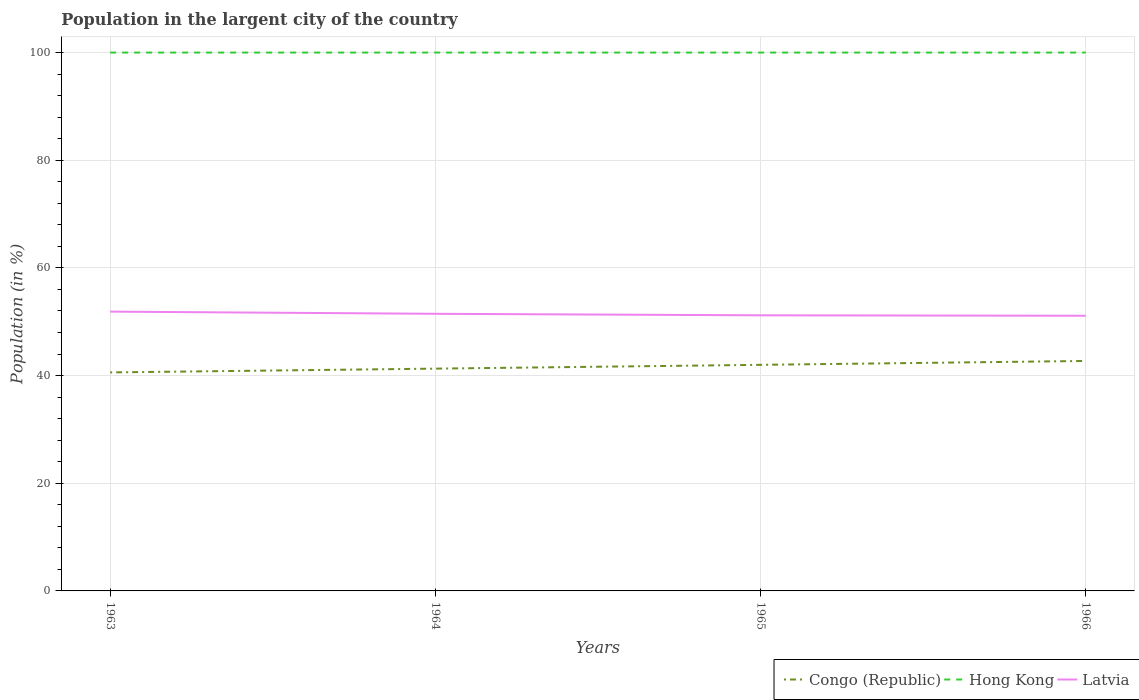Is the number of lines equal to the number of legend labels?
Offer a terse response. Yes. Across all years, what is the maximum percentage of population in the largent city in Latvia?
Give a very brief answer. 51.11. In which year was the percentage of population in the largent city in Latvia maximum?
Give a very brief answer. 1966. What is the total percentage of population in the largent city in Congo (Republic) in the graph?
Keep it short and to the point. -1.41. What is the difference between the highest and the second highest percentage of population in the largent city in Latvia?
Your answer should be compact. 0.77. What is the difference between the highest and the lowest percentage of population in the largent city in Hong Kong?
Offer a terse response. 0. Is the percentage of population in the largent city in Latvia strictly greater than the percentage of population in the largent city in Hong Kong over the years?
Provide a short and direct response. Yes. How many lines are there?
Keep it short and to the point. 3. How many years are there in the graph?
Ensure brevity in your answer.  4. What is the title of the graph?
Offer a very short reply. Population in the largent city of the country. Does "Russian Federation" appear as one of the legend labels in the graph?
Ensure brevity in your answer.  No. What is the Population (in %) of Congo (Republic) in 1963?
Provide a succinct answer. 40.59. What is the Population (in %) of Hong Kong in 1963?
Your response must be concise. 100. What is the Population (in %) in Latvia in 1963?
Make the answer very short. 51.88. What is the Population (in %) in Congo (Republic) in 1964?
Your response must be concise. 41.29. What is the Population (in %) of Latvia in 1964?
Offer a terse response. 51.48. What is the Population (in %) of Congo (Republic) in 1965?
Your answer should be very brief. 42. What is the Population (in %) in Latvia in 1965?
Offer a terse response. 51.19. What is the Population (in %) of Congo (Republic) in 1966?
Give a very brief answer. 42.72. What is the Population (in %) in Hong Kong in 1966?
Your answer should be compact. 100. What is the Population (in %) in Latvia in 1966?
Make the answer very short. 51.11. Across all years, what is the maximum Population (in %) of Congo (Republic)?
Provide a succinct answer. 42.72. Across all years, what is the maximum Population (in %) of Latvia?
Offer a very short reply. 51.88. Across all years, what is the minimum Population (in %) of Congo (Republic)?
Your answer should be compact. 40.59. Across all years, what is the minimum Population (in %) in Hong Kong?
Make the answer very short. 100. Across all years, what is the minimum Population (in %) in Latvia?
Keep it short and to the point. 51.11. What is the total Population (in %) of Congo (Republic) in the graph?
Offer a terse response. 166.59. What is the total Population (in %) in Latvia in the graph?
Give a very brief answer. 205.66. What is the difference between the Population (in %) of Congo (Republic) in 1963 and that in 1964?
Keep it short and to the point. -0.7. What is the difference between the Population (in %) in Latvia in 1963 and that in 1964?
Provide a short and direct response. 0.4. What is the difference between the Population (in %) in Congo (Republic) in 1963 and that in 1965?
Ensure brevity in your answer.  -1.41. What is the difference between the Population (in %) of Hong Kong in 1963 and that in 1965?
Make the answer very short. 0. What is the difference between the Population (in %) of Latvia in 1963 and that in 1965?
Offer a terse response. 0.69. What is the difference between the Population (in %) of Congo (Republic) in 1963 and that in 1966?
Offer a very short reply. -2.13. What is the difference between the Population (in %) in Hong Kong in 1963 and that in 1966?
Your response must be concise. 0. What is the difference between the Population (in %) in Latvia in 1963 and that in 1966?
Offer a terse response. 0.77. What is the difference between the Population (in %) of Congo (Republic) in 1964 and that in 1965?
Make the answer very short. -0.71. What is the difference between the Population (in %) of Latvia in 1964 and that in 1965?
Make the answer very short. 0.28. What is the difference between the Population (in %) of Congo (Republic) in 1964 and that in 1966?
Your answer should be compact. -1.43. What is the difference between the Population (in %) of Hong Kong in 1964 and that in 1966?
Offer a terse response. 0. What is the difference between the Population (in %) of Latvia in 1964 and that in 1966?
Your response must be concise. 0.36. What is the difference between the Population (in %) of Congo (Republic) in 1965 and that in 1966?
Offer a terse response. -0.72. What is the difference between the Population (in %) of Hong Kong in 1965 and that in 1966?
Your answer should be very brief. 0. What is the difference between the Population (in %) of Latvia in 1965 and that in 1966?
Offer a terse response. 0.08. What is the difference between the Population (in %) in Congo (Republic) in 1963 and the Population (in %) in Hong Kong in 1964?
Your answer should be very brief. -59.41. What is the difference between the Population (in %) of Congo (Republic) in 1963 and the Population (in %) of Latvia in 1964?
Offer a very short reply. -10.89. What is the difference between the Population (in %) of Hong Kong in 1963 and the Population (in %) of Latvia in 1964?
Offer a very short reply. 48.52. What is the difference between the Population (in %) in Congo (Republic) in 1963 and the Population (in %) in Hong Kong in 1965?
Give a very brief answer. -59.41. What is the difference between the Population (in %) of Congo (Republic) in 1963 and the Population (in %) of Latvia in 1965?
Give a very brief answer. -10.61. What is the difference between the Population (in %) in Hong Kong in 1963 and the Population (in %) in Latvia in 1965?
Make the answer very short. 48.81. What is the difference between the Population (in %) in Congo (Republic) in 1963 and the Population (in %) in Hong Kong in 1966?
Your response must be concise. -59.41. What is the difference between the Population (in %) of Congo (Republic) in 1963 and the Population (in %) of Latvia in 1966?
Provide a succinct answer. -10.52. What is the difference between the Population (in %) of Hong Kong in 1963 and the Population (in %) of Latvia in 1966?
Your answer should be very brief. 48.89. What is the difference between the Population (in %) of Congo (Republic) in 1964 and the Population (in %) of Hong Kong in 1965?
Give a very brief answer. -58.71. What is the difference between the Population (in %) of Congo (Republic) in 1964 and the Population (in %) of Latvia in 1965?
Make the answer very short. -9.9. What is the difference between the Population (in %) of Hong Kong in 1964 and the Population (in %) of Latvia in 1965?
Make the answer very short. 48.81. What is the difference between the Population (in %) in Congo (Republic) in 1964 and the Population (in %) in Hong Kong in 1966?
Your response must be concise. -58.71. What is the difference between the Population (in %) of Congo (Republic) in 1964 and the Population (in %) of Latvia in 1966?
Offer a terse response. -9.82. What is the difference between the Population (in %) in Hong Kong in 1964 and the Population (in %) in Latvia in 1966?
Make the answer very short. 48.89. What is the difference between the Population (in %) in Congo (Republic) in 1965 and the Population (in %) in Hong Kong in 1966?
Ensure brevity in your answer.  -58. What is the difference between the Population (in %) in Congo (Republic) in 1965 and the Population (in %) in Latvia in 1966?
Provide a succinct answer. -9.12. What is the difference between the Population (in %) in Hong Kong in 1965 and the Population (in %) in Latvia in 1966?
Ensure brevity in your answer.  48.89. What is the average Population (in %) in Congo (Republic) per year?
Give a very brief answer. 41.65. What is the average Population (in %) of Hong Kong per year?
Your response must be concise. 100. What is the average Population (in %) of Latvia per year?
Your answer should be compact. 51.42. In the year 1963, what is the difference between the Population (in %) of Congo (Republic) and Population (in %) of Hong Kong?
Make the answer very short. -59.41. In the year 1963, what is the difference between the Population (in %) in Congo (Republic) and Population (in %) in Latvia?
Give a very brief answer. -11.29. In the year 1963, what is the difference between the Population (in %) of Hong Kong and Population (in %) of Latvia?
Make the answer very short. 48.12. In the year 1964, what is the difference between the Population (in %) in Congo (Republic) and Population (in %) in Hong Kong?
Ensure brevity in your answer.  -58.71. In the year 1964, what is the difference between the Population (in %) of Congo (Republic) and Population (in %) of Latvia?
Ensure brevity in your answer.  -10.18. In the year 1964, what is the difference between the Population (in %) in Hong Kong and Population (in %) in Latvia?
Make the answer very short. 48.52. In the year 1965, what is the difference between the Population (in %) of Congo (Republic) and Population (in %) of Hong Kong?
Keep it short and to the point. -58. In the year 1965, what is the difference between the Population (in %) of Congo (Republic) and Population (in %) of Latvia?
Your response must be concise. -9.2. In the year 1965, what is the difference between the Population (in %) of Hong Kong and Population (in %) of Latvia?
Keep it short and to the point. 48.81. In the year 1966, what is the difference between the Population (in %) in Congo (Republic) and Population (in %) in Hong Kong?
Provide a short and direct response. -57.28. In the year 1966, what is the difference between the Population (in %) of Congo (Republic) and Population (in %) of Latvia?
Keep it short and to the point. -8.4. In the year 1966, what is the difference between the Population (in %) of Hong Kong and Population (in %) of Latvia?
Your answer should be very brief. 48.89. What is the ratio of the Population (in %) in Congo (Republic) in 1963 to that in 1964?
Give a very brief answer. 0.98. What is the ratio of the Population (in %) of Hong Kong in 1963 to that in 1964?
Keep it short and to the point. 1. What is the ratio of the Population (in %) of Latvia in 1963 to that in 1964?
Offer a terse response. 1.01. What is the ratio of the Population (in %) in Congo (Republic) in 1963 to that in 1965?
Keep it short and to the point. 0.97. What is the ratio of the Population (in %) of Hong Kong in 1963 to that in 1965?
Your answer should be very brief. 1. What is the ratio of the Population (in %) in Latvia in 1963 to that in 1965?
Offer a very short reply. 1.01. What is the ratio of the Population (in %) of Congo (Republic) in 1963 to that in 1966?
Provide a succinct answer. 0.95. What is the ratio of the Population (in %) in Latvia in 1963 to that in 1966?
Offer a very short reply. 1.01. What is the ratio of the Population (in %) of Congo (Republic) in 1964 to that in 1965?
Provide a short and direct response. 0.98. What is the ratio of the Population (in %) of Hong Kong in 1964 to that in 1965?
Provide a short and direct response. 1. What is the ratio of the Population (in %) of Congo (Republic) in 1964 to that in 1966?
Provide a short and direct response. 0.97. What is the ratio of the Population (in %) of Hong Kong in 1964 to that in 1966?
Your answer should be compact. 1. What is the ratio of the Population (in %) in Latvia in 1964 to that in 1966?
Ensure brevity in your answer.  1.01. What is the ratio of the Population (in %) in Congo (Republic) in 1965 to that in 1966?
Ensure brevity in your answer.  0.98. What is the difference between the highest and the second highest Population (in %) in Congo (Republic)?
Your answer should be compact. 0.72. What is the difference between the highest and the second highest Population (in %) of Hong Kong?
Ensure brevity in your answer.  0. What is the difference between the highest and the second highest Population (in %) in Latvia?
Offer a very short reply. 0.4. What is the difference between the highest and the lowest Population (in %) of Congo (Republic)?
Provide a succinct answer. 2.13. What is the difference between the highest and the lowest Population (in %) of Hong Kong?
Your answer should be very brief. 0. What is the difference between the highest and the lowest Population (in %) in Latvia?
Provide a succinct answer. 0.77. 